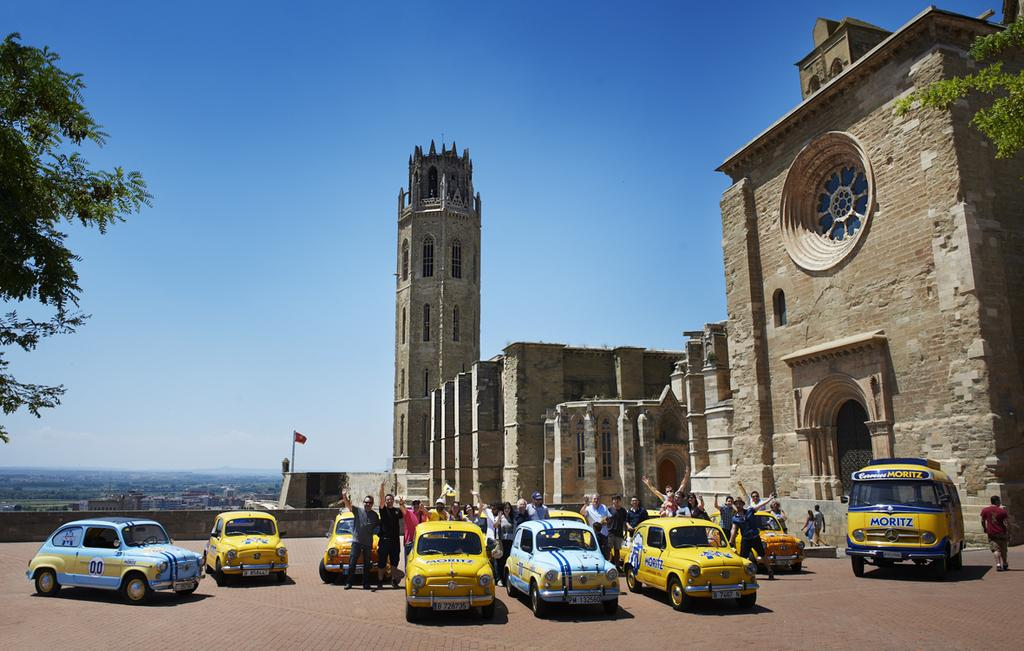<image>
Provide a brief description of the given image. A group of sports cars that say Moritz are parked by a cathedral. 